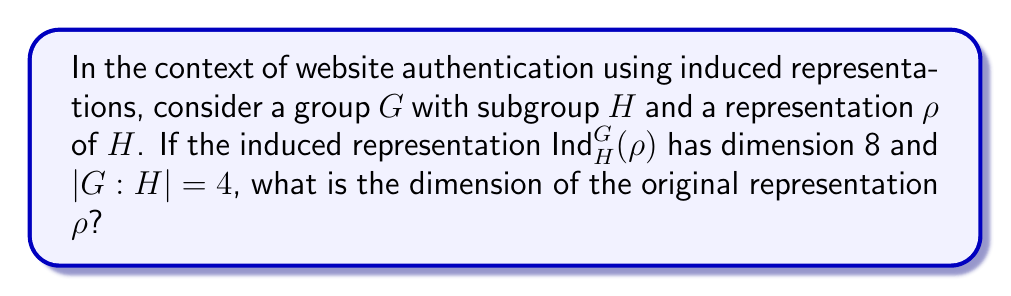Teach me how to tackle this problem. Let's approach this step-by-step:

1) The formula for the dimension of an induced representation is:

   $$\dim(\text{Ind}_H^G(\rho)) = |G:H| \cdot \dim(\rho)$$

   Where $|G:H|$ is the index of $H$ in $G$.

2) We are given that:
   
   $\dim(\text{Ind}_H^G(\rho)) = 8$
   $|G:H| = 4$

3) Substituting these values into the formula:

   $$8 = 4 \cdot \dim(\rho)$$

4) To solve for $\dim(\rho)$, we divide both sides by 4:

   $$\frac{8}{4} = \dim(\rho)$$

5) Simplifying:

   $$2 = \dim(\rho)$$

Therefore, the dimension of the original representation $\rho$ is 2.
Answer: 2 